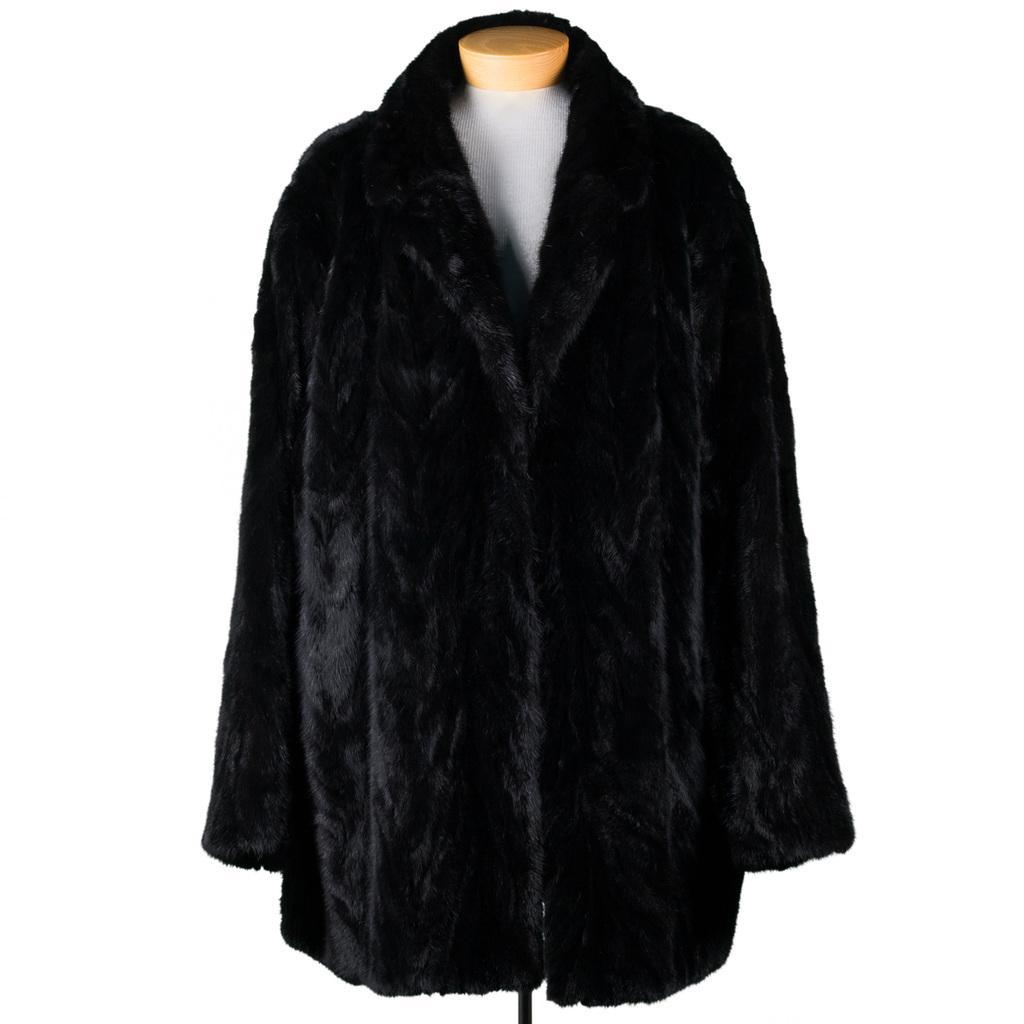Describe this image in one or two sentences. In this picture I can see the black color jacket on the white color thing and I see that it is white in the background. 